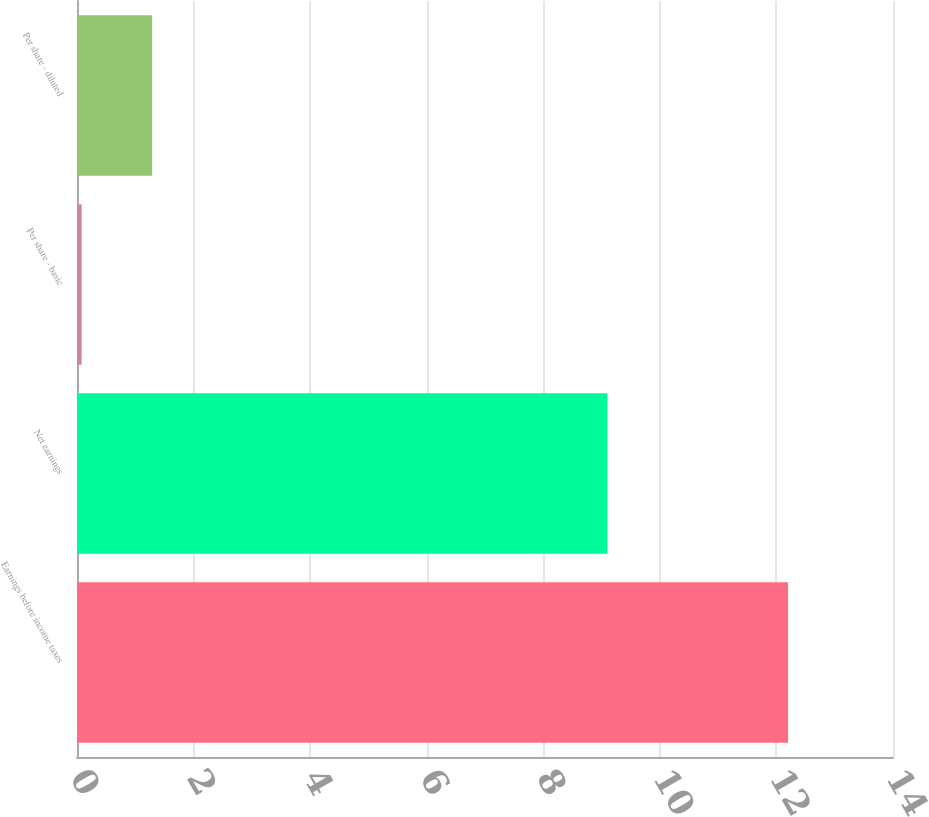Convert chart to OTSL. <chart><loc_0><loc_0><loc_500><loc_500><bar_chart><fcel>Earnings before income taxes<fcel>Net earnings<fcel>Per share - basic<fcel>Per share - diluted<nl><fcel>12.2<fcel>9.1<fcel>0.08<fcel>1.29<nl></chart> 